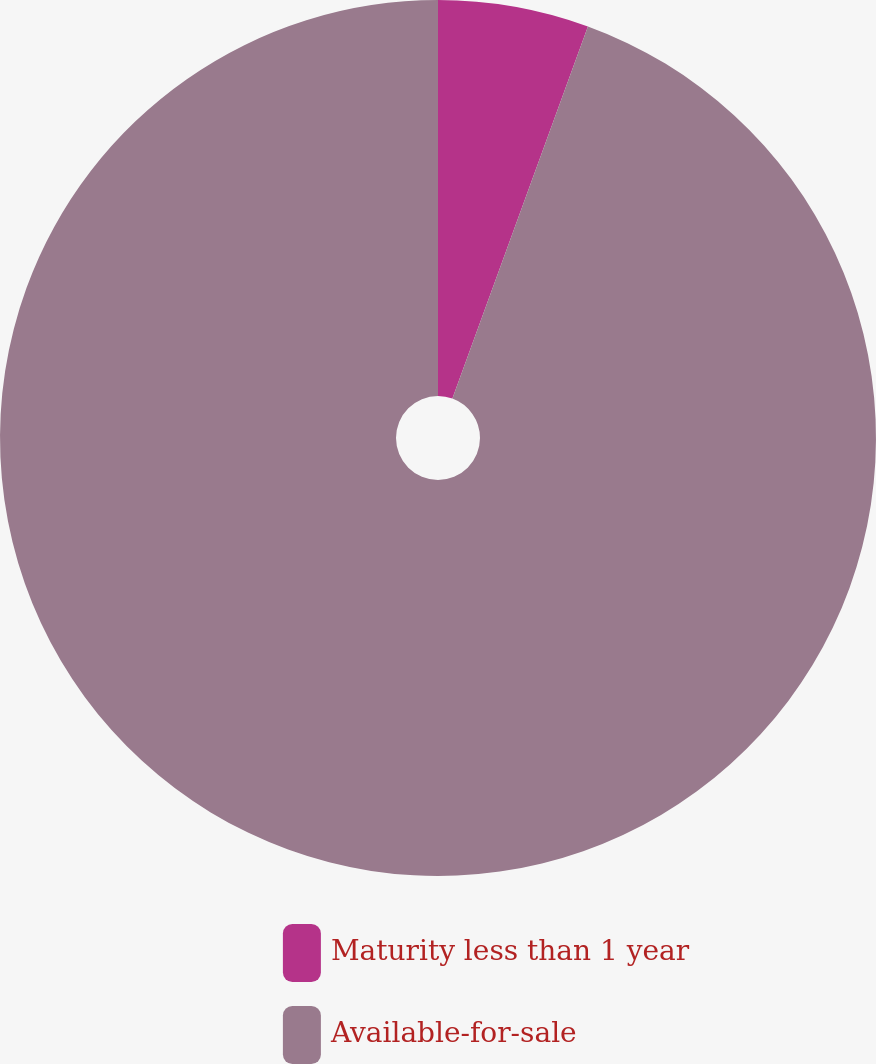Convert chart to OTSL. <chart><loc_0><loc_0><loc_500><loc_500><pie_chart><fcel>Maturity less than 1 year<fcel>Available-for-sale<nl><fcel>5.56%<fcel>94.44%<nl></chart> 